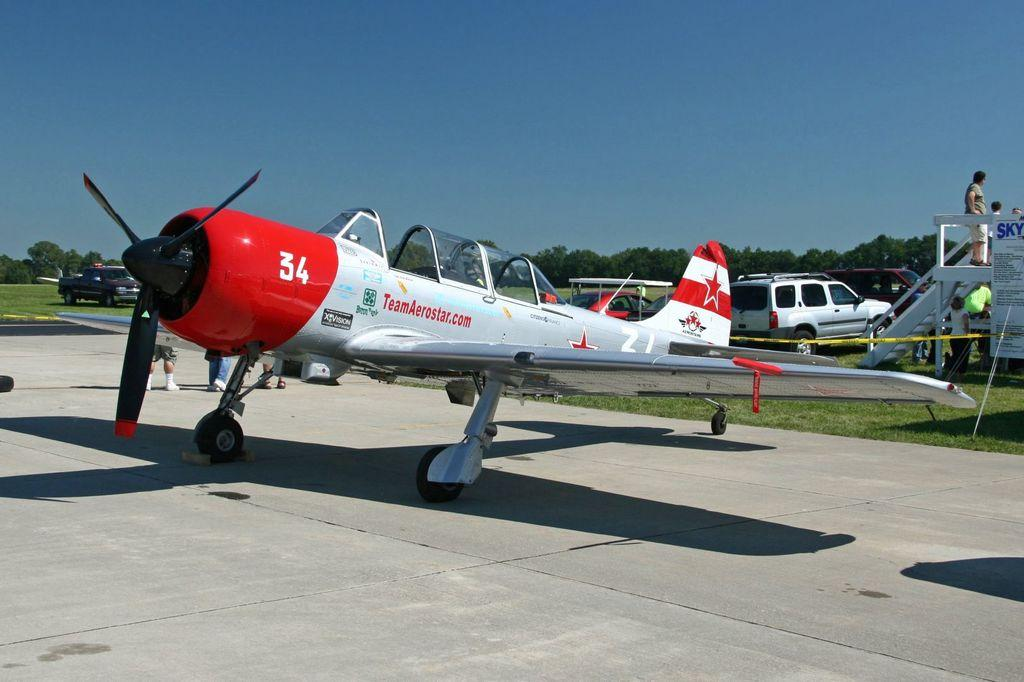<image>
Provide a brief description of the given image. A small propeller plane with the website TeamAerostar.com printed on the side. 